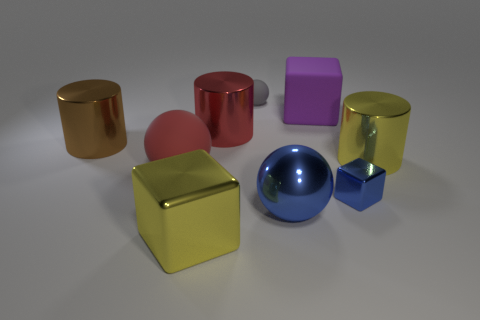Add 1 red metallic cylinders. How many objects exist? 10 Subtract all cylinders. How many objects are left? 6 Subtract all red balls. Subtract all purple things. How many objects are left? 7 Add 3 gray spheres. How many gray spheres are left? 4 Add 4 large yellow matte objects. How many large yellow matte objects exist? 4 Subtract 1 blue balls. How many objects are left? 8 